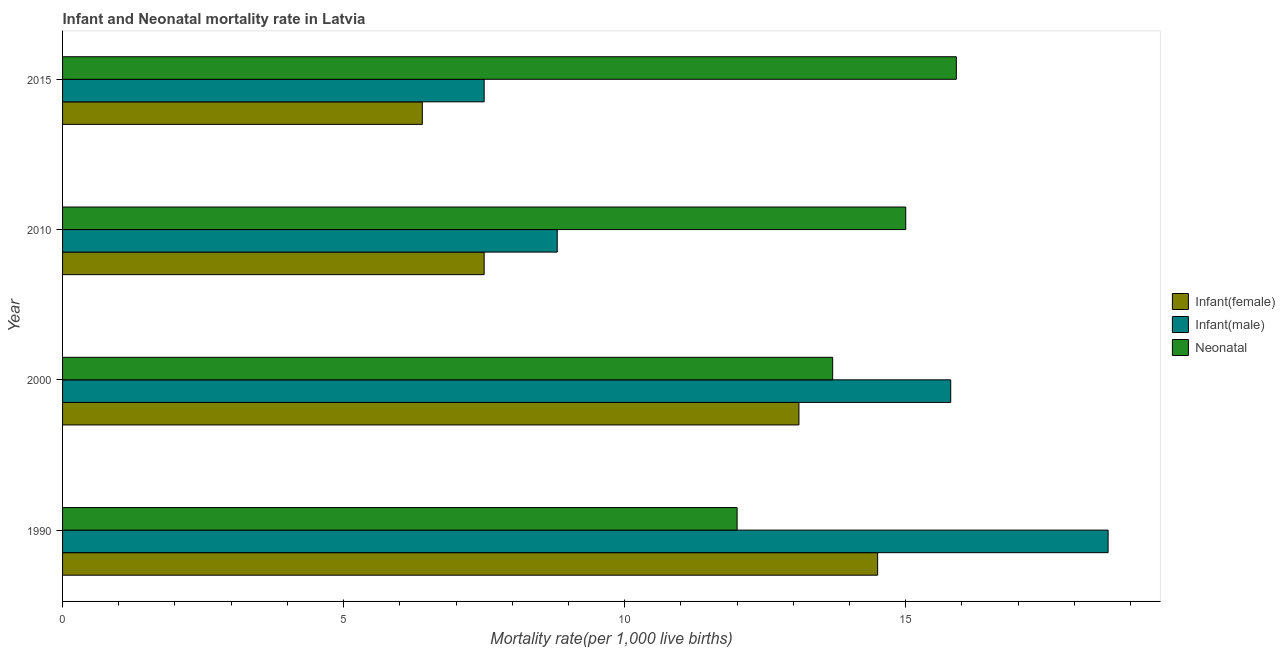Are the number of bars per tick equal to the number of legend labels?
Your answer should be compact. Yes. Are the number of bars on each tick of the Y-axis equal?
Make the answer very short. Yes. What is the label of the 1st group of bars from the top?
Offer a terse response. 2015. In which year was the infant mortality rate(male) maximum?
Give a very brief answer. 1990. In which year was the neonatal mortality rate minimum?
Make the answer very short. 1990. What is the total infant mortality rate(male) in the graph?
Provide a succinct answer. 50.7. What is the difference between the infant mortality rate(male) in 1990 and that in 2010?
Your response must be concise. 9.8. What is the difference between the neonatal mortality rate in 2000 and the infant mortality rate(female) in 1990?
Ensure brevity in your answer.  -0.8. What is the average neonatal mortality rate per year?
Provide a short and direct response. 14.15. In how many years, is the infant mortality rate(male) greater than 6 ?
Offer a very short reply. 4. What is the ratio of the infant mortality rate(female) in 1990 to that in 2015?
Your response must be concise. 2.27. Is the neonatal mortality rate in 1990 less than that in 2010?
Your response must be concise. Yes. What does the 3rd bar from the top in 2015 represents?
Ensure brevity in your answer.  Infant(female). What does the 2nd bar from the bottom in 1990 represents?
Keep it short and to the point. Infant(male). Is it the case that in every year, the sum of the infant mortality rate(female) and infant mortality rate(male) is greater than the neonatal mortality rate?
Offer a terse response. No. What is the difference between two consecutive major ticks on the X-axis?
Your answer should be compact. 5. Are the values on the major ticks of X-axis written in scientific E-notation?
Make the answer very short. No. What is the title of the graph?
Your response must be concise. Infant and Neonatal mortality rate in Latvia. Does "Agricultural raw materials" appear as one of the legend labels in the graph?
Provide a succinct answer. No. What is the label or title of the X-axis?
Your answer should be very brief. Mortality rate(per 1,0 live births). What is the label or title of the Y-axis?
Offer a terse response. Year. What is the Mortality rate(per 1,000 live births) in Infant(female) in 1990?
Your answer should be very brief. 14.5. What is the Mortality rate(per 1,000 live births) in Infant(male) in 2000?
Your response must be concise. 15.8. What is the Mortality rate(per 1,000 live births) in Infant(female) in 2010?
Offer a very short reply. 7.5. What is the Mortality rate(per 1,000 live births) of Infant(male) in 2010?
Your answer should be compact. 8.8. What is the Mortality rate(per 1,000 live births) in Infant(female) in 2015?
Provide a short and direct response. 6.4. Across all years, what is the maximum Mortality rate(per 1,000 live births) of Infant(female)?
Ensure brevity in your answer.  14.5. Across all years, what is the maximum Mortality rate(per 1,000 live births) of Neonatal ?
Keep it short and to the point. 15.9. Across all years, what is the minimum Mortality rate(per 1,000 live births) in Neonatal ?
Keep it short and to the point. 12. What is the total Mortality rate(per 1,000 live births) in Infant(female) in the graph?
Your response must be concise. 41.5. What is the total Mortality rate(per 1,000 live births) in Infant(male) in the graph?
Give a very brief answer. 50.7. What is the total Mortality rate(per 1,000 live births) in Neonatal  in the graph?
Ensure brevity in your answer.  56.6. What is the difference between the Mortality rate(per 1,000 live births) of Infant(female) in 1990 and that in 2000?
Give a very brief answer. 1.4. What is the difference between the Mortality rate(per 1,000 live births) of Infant(female) in 1990 and that in 2010?
Offer a terse response. 7. What is the difference between the Mortality rate(per 1,000 live births) in Infant(male) in 1990 and that in 2010?
Provide a succinct answer. 9.8. What is the difference between the Mortality rate(per 1,000 live births) of Neonatal  in 1990 and that in 2010?
Make the answer very short. -3. What is the difference between the Mortality rate(per 1,000 live births) of Infant(female) in 1990 and that in 2015?
Give a very brief answer. 8.1. What is the difference between the Mortality rate(per 1,000 live births) of Neonatal  in 1990 and that in 2015?
Offer a very short reply. -3.9. What is the difference between the Mortality rate(per 1,000 live births) of Infant(male) in 2000 and that in 2010?
Provide a succinct answer. 7. What is the difference between the Mortality rate(per 1,000 live births) in Infant(female) in 2000 and that in 2015?
Your answer should be very brief. 6.7. What is the difference between the Mortality rate(per 1,000 live births) in Neonatal  in 2000 and that in 2015?
Provide a short and direct response. -2.2. What is the difference between the Mortality rate(per 1,000 live births) in Infant(male) in 2010 and that in 2015?
Your answer should be very brief. 1.3. What is the difference between the Mortality rate(per 1,000 live births) of Infant(female) in 1990 and the Mortality rate(per 1,000 live births) of Infant(male) in 2000?
Make the answer very short. -1.3. What is the difference between the Mortality rate(per 1,000 live births) of Infant(female) in 1990 and the Mortality rate(per 1,000 live births) of Neonatal  in 2000?
Make the answer very short. 0.8. What is the difference between the Mortality rate(per 1,000 live births) of Infant(female) in 1990 and the Mortality rate(per 1,000 live births) of Infant(male) in 2010?
Provide a succinct answer. 5.7. What is the difference between the Mortality rate(per 1,000 live births) of Infant(male) in 1990 and the Mortality rate(per 1,000 live births) of Neonatal  in 2010?
Give a very brief answer. 3.6. What is the difference between the Mortality rate(per 1,000 live births) in Infant(female) in 1990 and the Mortality rate(per 1,000 live births) in Infant(male) in 2015?
Your answer should be very brief. 7. What is the difference between the Mortality rate(per 1,000 live births) of Infant(female) in 1990 and the Mortality rate(per 1,000 live births) of Neonatal  in 2015?
Your answer should be very brief. -1.4. What is the difference between the Mortality rate(per 1,000 live births) of Infant(male) in 1990 and the Mortality rate(per 1,000 live births) of Neonatal  in 2015?
Provide a succinct answer. 2.7. What is the difference between the Mortality rate(per 1,000 live births) in Infant(female) in 2000 and the Mortality rate(per 1,000 live births) in Infant(male) in 2010?
Ensure brevity in your answer.  4.3. What is the difference between the Mortality rate(per 1,000 live births) in Infant(female) in 2000 and the Mortality rate(per 1,000 live births) in Neonatal  in 2010?
Provide a succinct answer. -1.9. What is the difference between the Mortality rate(per 1,000 live births) of Infant(female) in 2000 and the Mortality rate(per 1,000 live births) of Infant(male) in 2015?
Ensure brevity in your answer.  5.6. What is the difference between the Mortality rate(per 1,000 live births) in Infant(female) in 2000 and the Mortality rate(per 1,000 live births) in Neonatal  in 2015?
Your response must be concise. -2.8. What is the difference between the Mortality rate(per 1,000 live births) in Infant(male) in 2000 and the Mortality rate(per 1,000 live births) in Neonatal  in 2015?
Offer a very short reply. -0.1. What is the difference between the Mortality rate(per 1,000 live births) in Infant(female) in 2010 and the Mortality rate(per 1,000 live births) in Neonatal  in 2015?
Give a very brief answer. -8.4. What is the average Mortality rate(per 1,000 live births) in Infant(female) per year?
Offer a terse response. 10.38. What is the average Mortality rate(per 1,000 live births) in Infant(male) per year?
Your answer should be very brief. 12.68. What is the average Mortality rate(per 1,000 live births) in Neonatal  per year?
Your answer should be compact. 14.15. In the year 2000, what is the difference between the Mortality rate(per 1,000 live births) of Infant(female) and Mortality rate(per 1,000 live births) of Neonatal ?
Provide a succinct answer. -0.6. In the year 2000, what is the difference between the Mortality rate(per 1,000 live births) of Infant(male) and Mortality rate(per 1,000 live births) of Neonatal ?
Make the answer very short. 2.1. In the year 2010, what is the difference between the Mortality rate(per 1,000 live births) of Infant(female) and Mortality rate(per 1,000 live births) of Neonatal ?
Offer a very short reply. -7.5. In the year 2015, what is the difference between the Mortality rate(per 1,000 live births) in Infant(female) and Mortality rate(per 1,000 live births) in Infant(male)?
Provide a succinct answer. -1.1. In the year 2015, what is the difference between the Mortality rate(per 1,000 live births) of Infant(female) and Mortality rate(per 1,000 live births) of Neonatal ?
Provide a succinct answer. -9.5. In the year 2015, what is the difference between the Mortality rate(per 1,000 live births) in Infant(male) and Mortality rate(per 1,000 live births) in Neonatal ?
Provide a short and direct response. -8.4. What is the ratio of the Mortality rate(per 1,000 live births) in Infant(female) in 1990 to that in 2000?
Provide a succinct answer. 1.11. What is the ratio of the Mortality rate(per 1,000 live births) of Infant(male) in 1990 to that in 2000?
Offer a terse response. 1.18. What is the ratio of the Mortality rate(per 1,000 live births) of Neonatal  in 1990 to that in 2000?
Your response must be concise. 0.88. What is the ratio of the Mortality rate(per 1,000 live births) in Infant(female) in 1990 to that in 2010?
Keep it short and to the point. 1.93. What is the ratio of the Mortality rate(per 1,000 live births) of Infant(male) in 1990 to that in 2010?
Your response must be concise. 2.11. What is the ratio of the Mortality rate(per 1,000 live births) in Neonatal  in 1990 to that in 2010?
Ensure brevity in your answer.  0.8. What is the ratio of the Mortality rate(per 1,000 live births) in Infant(female) in 1990 to that in 2015?
Ensure brevity in your answer.  2.27. What is the ratio of the Mortality rate(per 1,000 live births) of Infant(male) in 1990 to that in 2015?
Your response must be concise. 2.48. What is the ratio of the Mortality rate(per 1,000 live births) in Neonatal  in 1990 to that in 2015?
Offer a very short reply. 0.75. What is the ratio of the Mortality rate(per 1,000 live births) in Infant(female) in 2000 to that in 2010?
Give a very brief answer. 1.75. What is the ratio of the Mortality rate(per 1,000 live births) in Infant(male) in 2000 to that in 2010?
Ensure brevity in your answer.  1.8. What is the ratio of the Mortality rate(per 1,000 live births) in Neonatal  in 2000 to that in 2010?
Provide a succinct answer. 0.91. What is the ratio of the Mortality rate(per 1,000 live births) in Infant(female) in 2000 to that in 2015?
Make the answer very short. 2.05. What is the ratio of the Mortality rate(per 1,000 live births) in Infant(male) in 2000 to that in 2015?
Offer a very short reply. 2.11. What is the ratio of the Mortality rate(per 1,000 live births) of Neonatal  in 2000 to that in 2015?
Make the answer very short. 0.86. What is the ratio of the Mortality rate(per 1,000 live births) of Infant(female) in 2010 to that in 2015?
Provide a succinct answer. 1.17. What is the ratio of the Mortality rate(per 1,000 live births) in Infant(male) in 2010 to that in 2015?
Provide a succinct answer. 1.17. What is the ratio of the Mortality rate(per 1,000 live births) of Neonatal  in 2010 to that in 2015?
Offer a terse response. 0.94. What is the difference between the highest and the second highest Mortality rate(per 1,000 live births) of Infant(male)?
Give a very brief answer. 2.8. What is the difference between the highest and the lowest Mortality rate(per 1,000 live births) in Infant(male)?
Give a very brief answer. 11.1. 